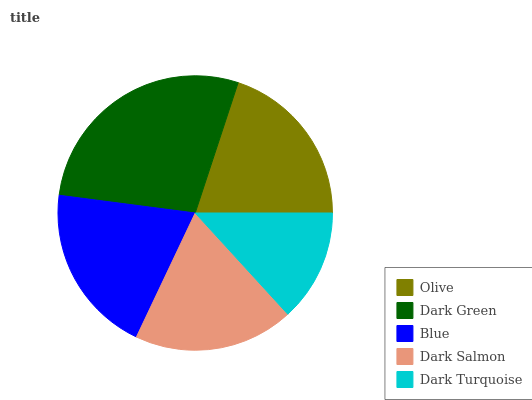Is Dark Turquoise the minimum?
Answer yes or no. Yes. Is Dark Green the maximum?
Answer yes or no. Yes. Is Blue the minimum?
Answer yes or no. No. Is Blue the maximum?
Answer yes or no. No. Is Dark Green greater than Blue?
Answer yes or no. Yes. Is Blue less than Dark Green?
Answer yes or no. Yes. Is Blue greater than Dark Green?
Answer yes or no. No. Is Dark Green less than Blue?
Answer yes or no. No. Is Olive the high median?
Answer yes or no. Yes. Is Olive the low median?
Answer yes or no. Yes. Is Dark Salmon the high median?
Answer yes or no. No. Is Blue the low median?
Answer yes or no. No. 